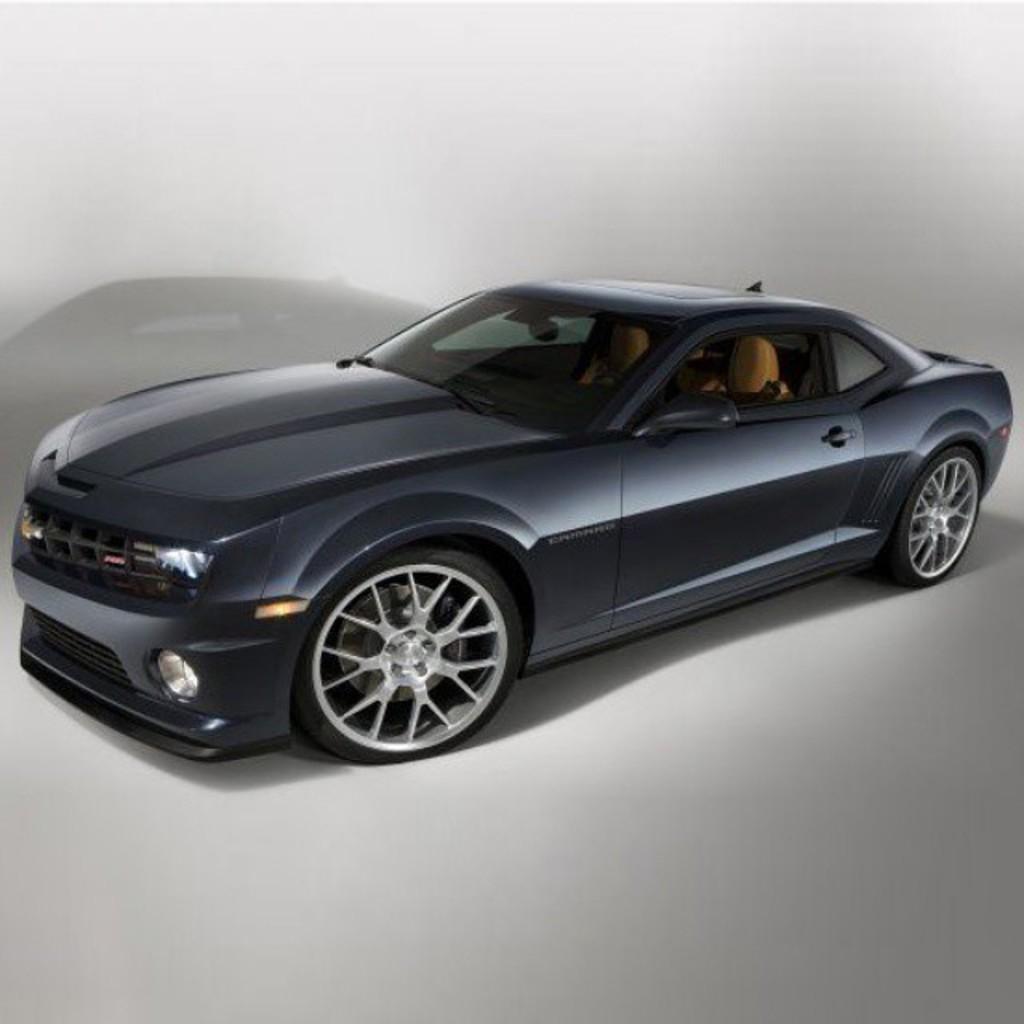Can you describe this image briefly? There is a black color car in the center of the image and the background is white. 